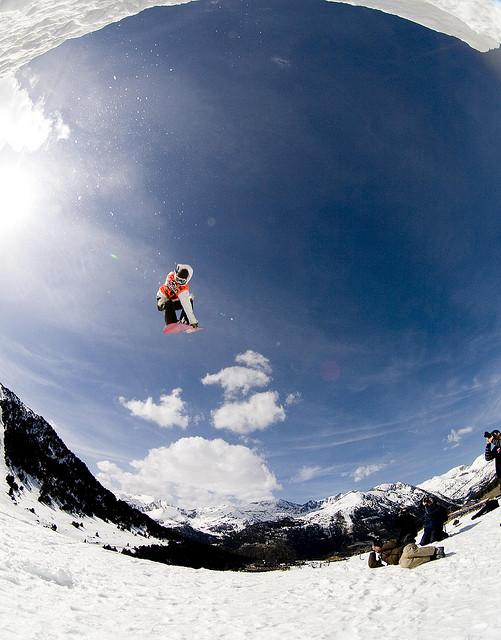What color is the sky?
Give a very brief answer. Blue. Is there snow on the ground?
Quick response, please. Yes. How many people are in this image?
Quick response, please. 4. 